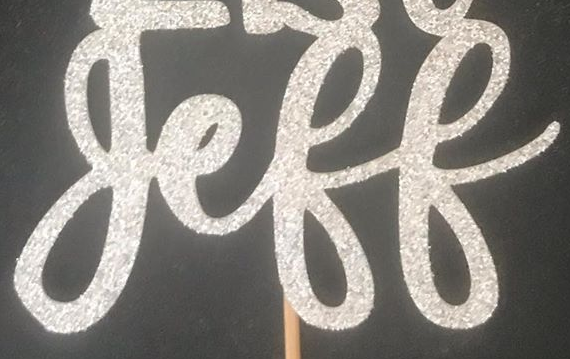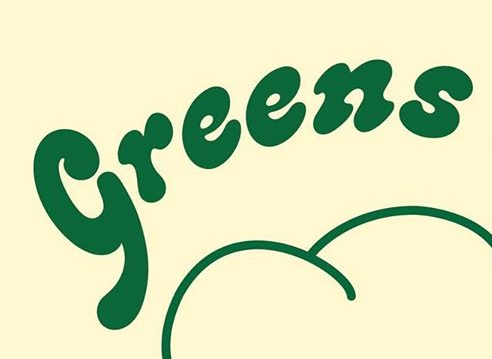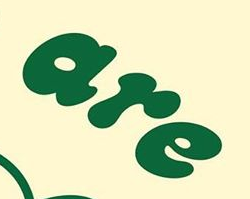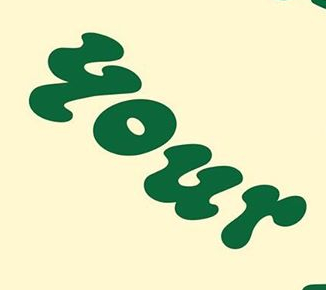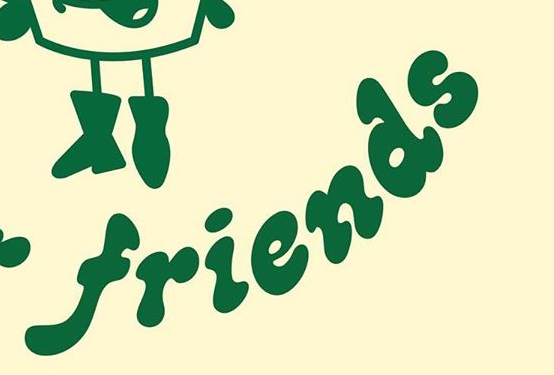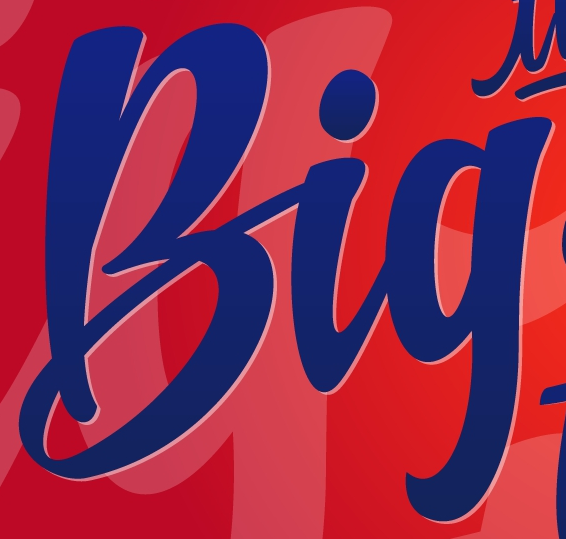Identify the words shown in these images in order, separated by a semicolon. geff; Greens; are; your; friends; Big 